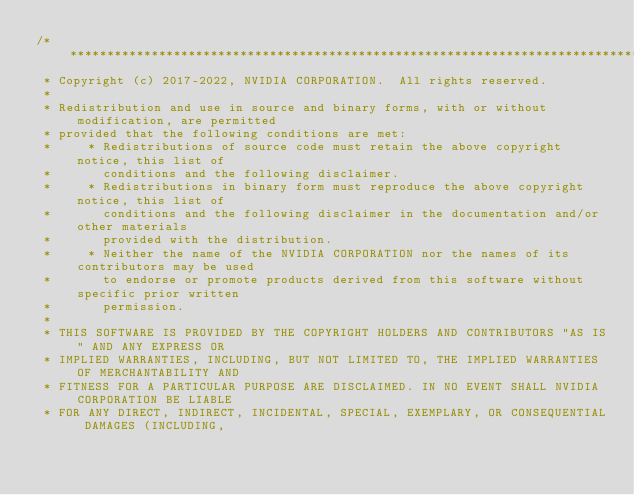Convert code to text. <code><loc_0><loc_0><loc_500><loc_500><_Cuda_>/***************************************************************************************************
 * Copyright (c) 2017-2022, NVIDIA CORPORATION.  All rights reserved.
 *
 * Redistribution and use in source and binary forms, with or without modification, are permitted
 * provided that the following conditions are met:
 *     * Redistributions of source code must retain the above copyright notice, this list of
 *       conditions and the following disclaimer.
 *     * Redistributions in binary form must reproduce the above copyright notice, this list of
 *       conditions and the following disclaimer in the documentation and/or other materials
 *       provided with the distribution.
 *     * Neither the name of the NVIDIA CORPORATION nor the names of its contributors may be used
 *       to endorse or promote products derived from this software without specific prior written
 *       permission.
 *
 * THIS SOFTWARE IS PROVIDED BY THE COPYRIGHT HOLDERS AND CONTRIBUTORS "AS IS" AND ANY EXPRESS OR
 * IMPLIED WARRANTIES, INCLUDING, BUT NOT LIMITED TO, THE IMPLIED WARRANTIES OF MERCHANTABILITY AND
 * FITNESS FOR A PARTICULAR PURPOSE ARE DISCLAIMED. IN NO EVENT SHALL NVIDIA CORPORATION BE LIABLE
 * FOR ANY DIRECT, INDIRECT, INCIDENTAL, SPECIAL, EXEMPLARY, OR CONSEQUENTIAL DAMAGES (INCLUDING,</code> 